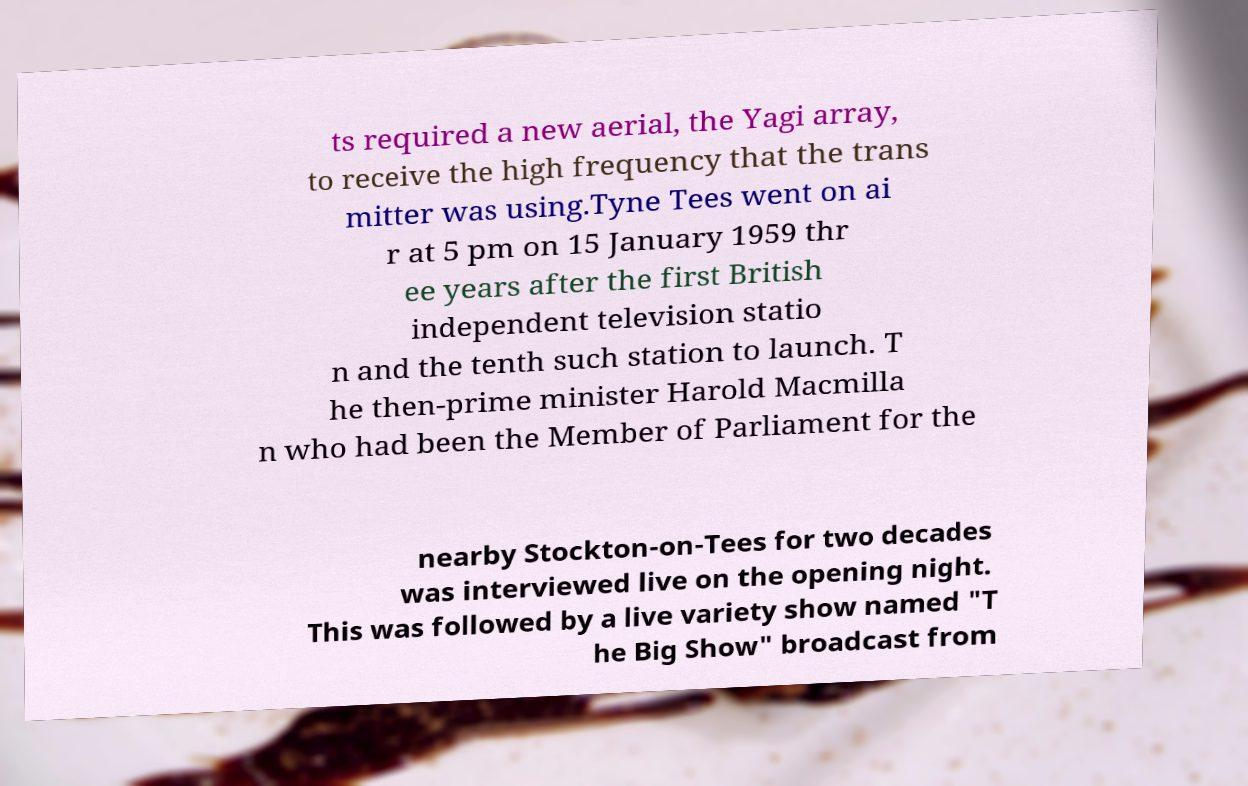For documentation purposes, I need the text within this image transcribed. Could you provide that? ts required a new aerial, the Yagi array, to receive the high frequency that the trans mitter was using.Tyne Tees went on ai r at 5 pm on 15 January 1959 thr ee years after the first British independent television statio n and the tenth such station to launch. T he then-prime minister Harold Macmilla n who had been the Member of Parliament for the nearby Stockton-on-Tees for two decades was interviewed live on the opening night. This was followed by a live variety show named "T he Big Show" broadcast from 